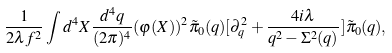<formula> <loc_0><loc_0><loc_500><loc_500>\frac { 1 } { 2 \lambda f ^ { 2 } } \int d ^ { 4 } X \frac { d ^ { 4 } q } { ( 2 \pi ) ^ { 4 } } ( \varphi ( X ) ) ^ { 2 } \tilde { \pi } _ { 0 } ( q ) [ \partial _ { q } ^ { 2 } + \frac { 4 i \lambda } { q ^ { 2 } - \Sigma ^ { 2 } ( q ) } ] \tilde { \pi } _ { 0 } ( q ) ,</formula> 